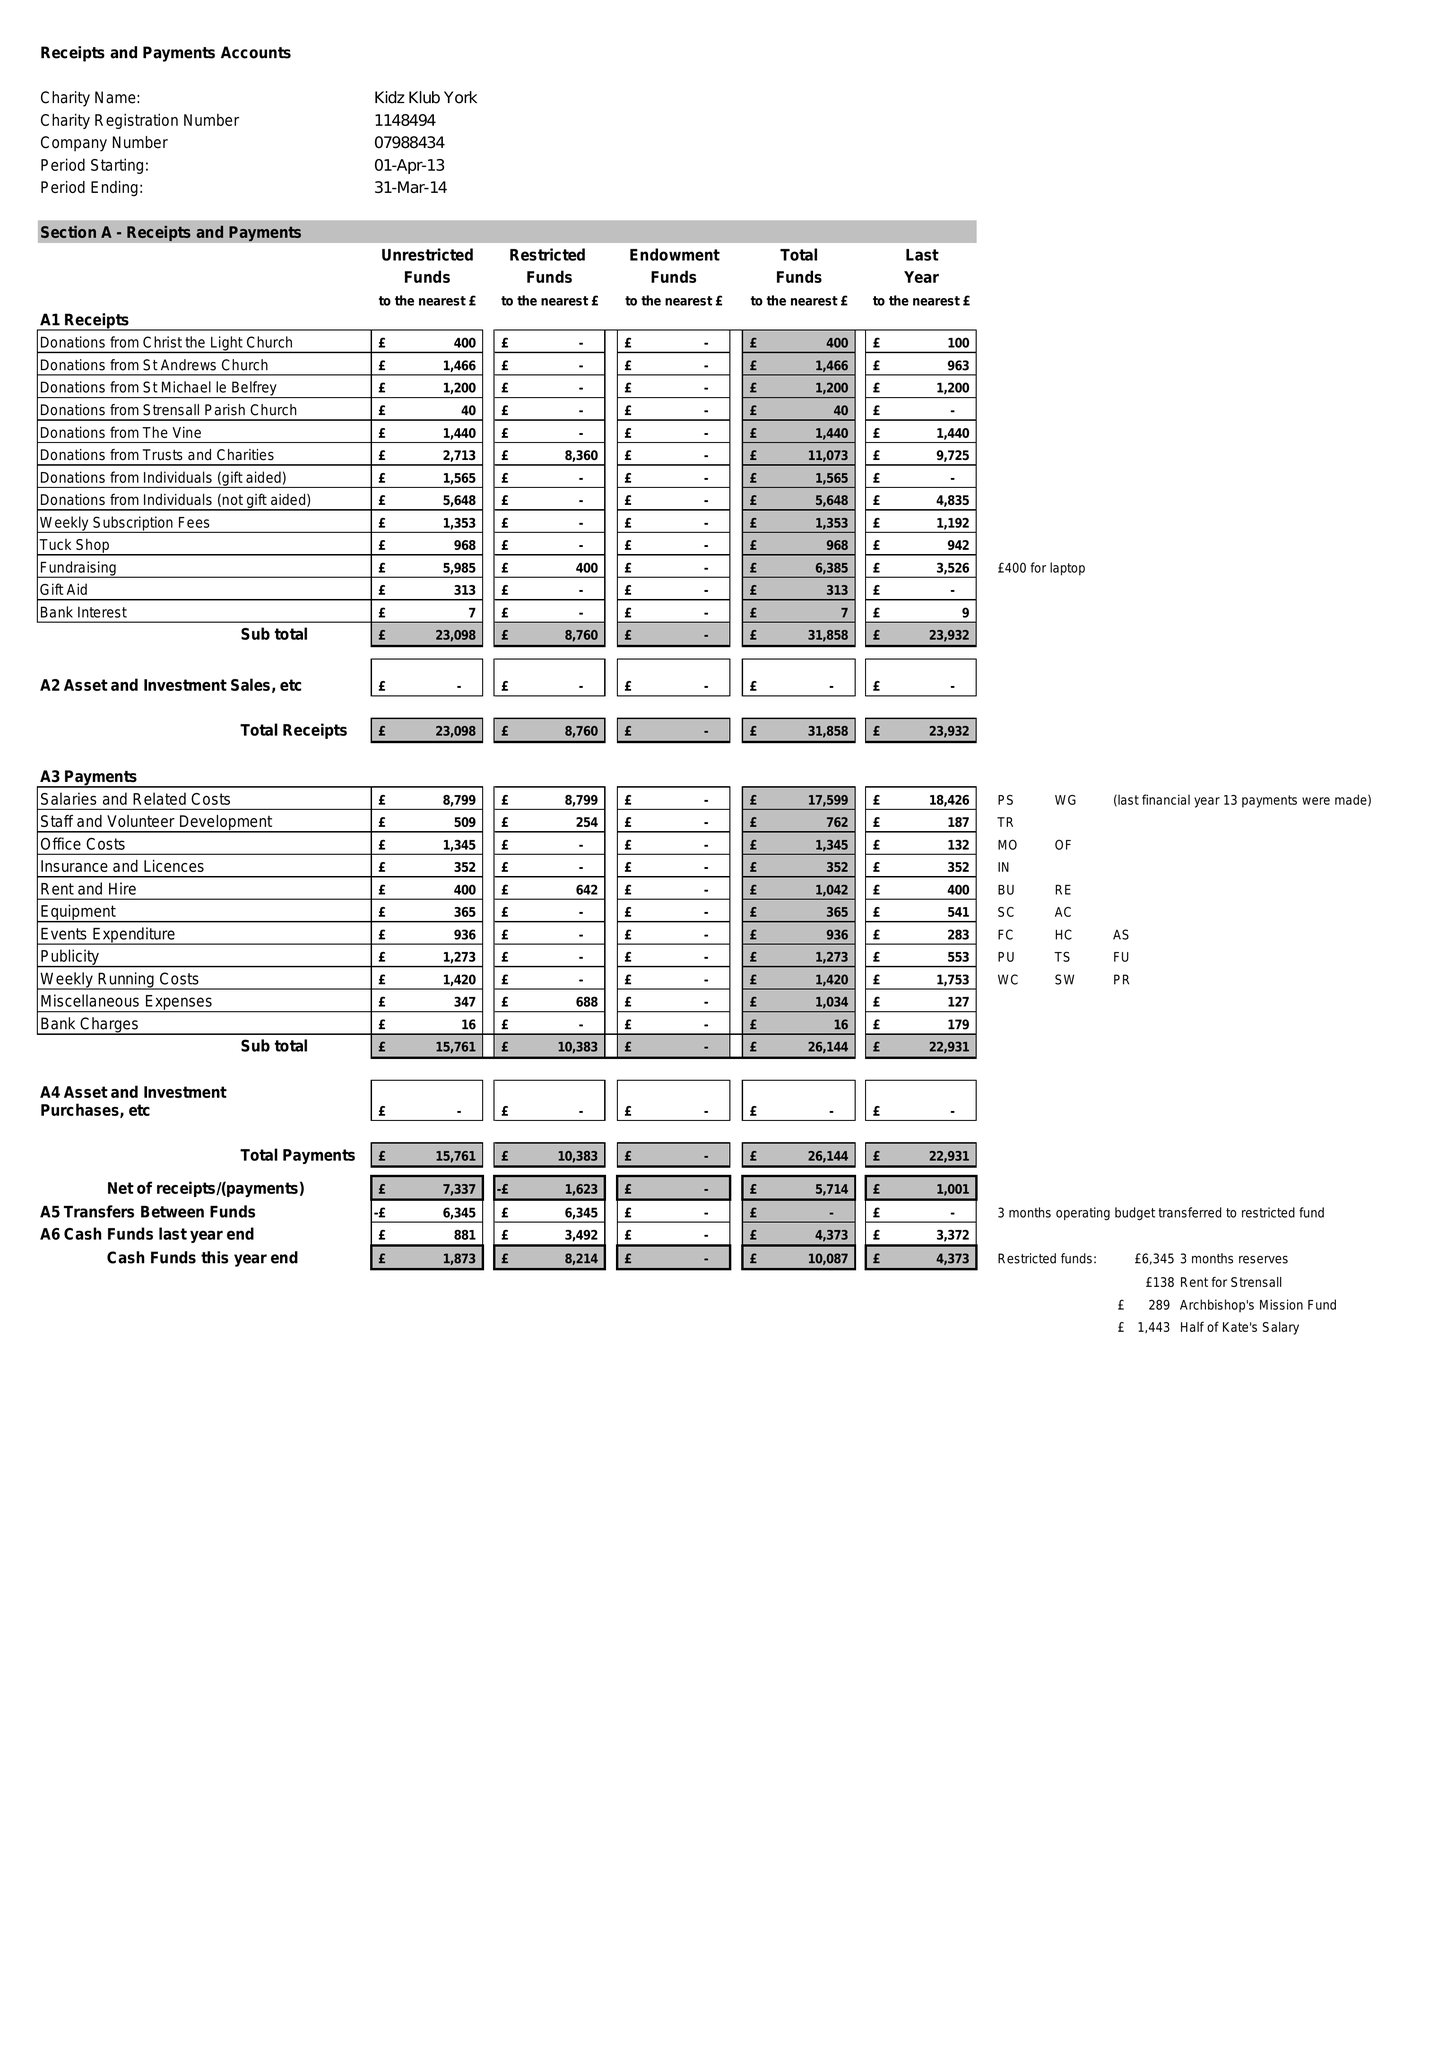What is the value for the address__post_town?
Answer the question using a single word or phrase. YORK 